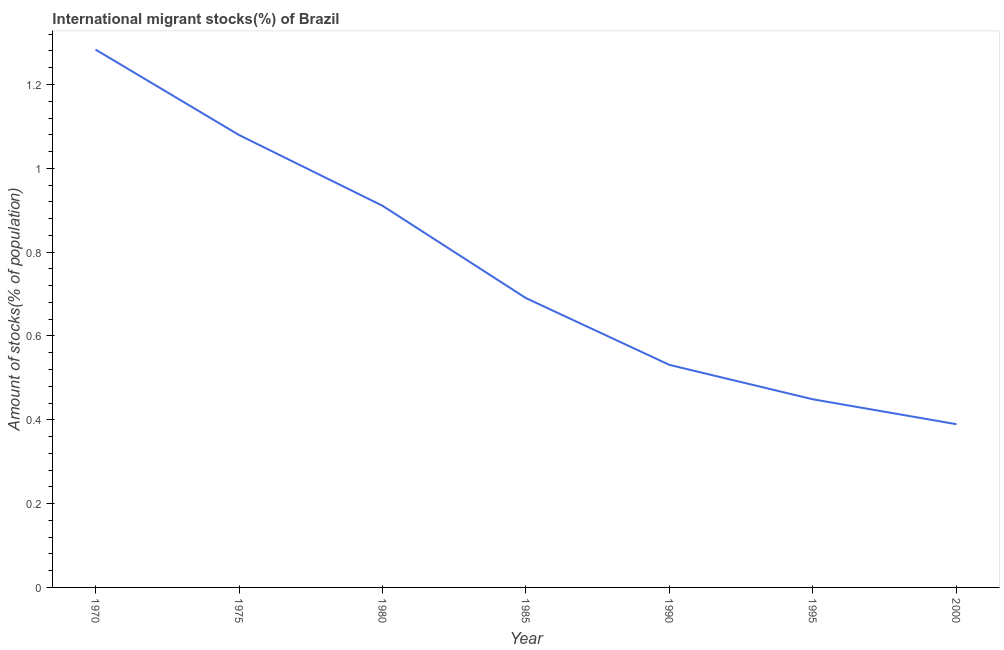What is the number of international migrant stocks in 1980?
Offer a very short reply. 0.91. Across all years, what is the maximum number of international migrant stocks?
Your response must be concise. 1.28. Across all years, what is the minimum number of international migrant stocks?
Give a very brief answer. 0.39. In which year was the number of international migrant stocks maximum?
Your answer should be very brief. 1970. In which year was the number of international migrant stocks minimum?
Offer a very short reply. 2000. What is the sum of the number of international migrant stocks?
Offer a very short reply. 5.33. What is the difference between the number of international migrant stocks in 1985 and 1995?
Make the answer very short. 0.24. What is the average number of international migrant stocks per year?
Your response must be concise. 0.76. What is the median number of international migrant stocks?
Make the answer very short. 0.69. In how many years, is the number of international migrant stocks greater than 0.6000000000000001 %?
Your response must be concise. 4. Do a majority of the years between 1995 and 1970 (inclusive) have number of international migrant stocks greater than 0.28 %?
Offer a very short reply. Yes. What is the ratio of the number of international migrant stocks in 1975 to that in 1985?
Offer a very short reply. 1.56. Is the difference between the number of international migrant stocks in 1970 and 1980 greater than the difference between any two years?
Keep it short and to the point. No. What is the difference between the highest and the second highest number of international migrant stocks?
Your answer should be compact. 0.2. Is the sum of the number of international migrant stocks in 1970 and 1990 greater than the maximum number of international migrant stocks across all years?
Offer a terse response. Yes. What is the difference between the highest and the lowest number of international migrant stocks?
Offer a terse response. 0.89. In how many years, is the number of international migrant stocks greater than the average number of international migrant stocks taken over all years?
Give a very brief answer. 3. What is the difference between two consecutive major ticks on the Y-axis?
Provide a succinct answer. 0.2. Does the graph contain any zero values?
Your response must be concise. No. What is the title of the graph?
Your answer should be very brief. International migrant stocks(%) of Brazil. What is the label or title of the X-axis?
Provide a short and direct response. Year. What is the label or title of the Y-axis?
Your answer should be compact. Amount of stocks(% of population). What is the Amount of stocks(% of population) of 1970?
Your response must be concise. 1.28. What is the Amount of stocks(% of population) of 1975?
Give a very brief answer. 1.08. What is the Amount of stocks(% of population) of 1980?
Your answer should be very brief. 0.91. What is the Amount of stocks(% of population) in 1985?
Ensure brevity in your answer.  0.69. What is the Amount of stocks(% of population) of 1990?
Give a very brief answer. 0.53. What is the Amount of stocks(% of population) of 1995?
Your response must be concise. 0.45. What is the Amount of stocks(% of population) in 2000?
Give a very brief answer. 0.39. What is the difference between the Amount of stocks(% of population) in 1970 and 1975?
Make the answer very short. 0.2. What is the difference between the Amount of stocks(% of population) in 1970 and 1980?
Your answer should be very brief. 0.37. What is the difference between the Amount of stocks(% of population) in 1970 and 1985?
Provide a short and direct response. 0.59. What is the difference between the Amount of stocks(% of population) in 1970 and 1990?
Your answer should be very brief. 0.75. What is the difference between the Amount of stocks(% of population) in 1970 and 1995?
Offer a terse response. 0.83. What is the difference between the Amount of stocks(% of population) in 1970 and 2000?
Provide a succinct answer. 0.89. What is the difference between the Amount of stocks(% of population) in 1975 and 1980?
Keep it short and to the point. 0.17. What is the difference between the Amount of stocks(% of population) in 1975 and 1985?
Offer a very short reply. 0.39. What is the difference between the Amount of stocks(% of population) in 1975 and 1990?
Offer a very short reply. 0.55. What is the difference between the Amount of stocks(% of population) in 1975 and 1995?
Offer a very short reply. 0.63. What is the difference between the Amount of stocks(% of population) in 1975 and 2000?
Keep it short and to the point. 0.69. What is the difference between the Amount of stocks(% of population) in 1980 and 1985?
Your response must be concise. 0.22. What is the difference between the Amount of stocks(% of population) in 1980 and 1990?
Your response must be concise. 0.38. What is the difference between the Amount of stocks(% of population) in 1980 and 1995?
Provide a short and direct response. 0.46. What is the difference between the Amount of stocks(% of population) in 1980 and 2000?
Keep it short and to the point. 0.52. What is the difference between the Amount of stocks(% of population) in 1985 and 1990?
Ensure brevity in your answer.  0.16. What is the difference between the Amount of stocks(% of population) in 1985 and 1995?
Provide a succinct answer. 0.24. What is the difference between the Amount of stocks(% of population) in 1985 and 2000?
Your answer should be compact. 0.3. What is the difference between the Amount of stocks(% of population) in 1990 and 1995?
Keep it short and to the point. 0.08. What is the difference between the Amount of stocks(% of population) in 1990 and 2000?
Give a very brief answer. 0.14. What is the difference between the Amount of stocks(% of population) in 1995 and 2000?
Your response must be concise. 0.06. What is the ratio of the Amount of stocks(% of population) in 1970 to that in 1975?
Offer a very short reply. 1.19. What is the ratio of the Amount of stocks(% of population) in 1970 to that in 1980?
Your answer should be very brief. 1.41. What is the ratio of the Amount of stocks(% of population) in 1970 to that in 1985?
Your answer should be compact. 1.86. What is the ratio of the Amount of stocks(% of population) in 1970 to that in 1990?
Offer a very short reply. 2.42. What is the ratio of the Amount of stocks(% of population) in 1970 to that in 1995?
Offer a terse response. 2.86. What is the ratio of the Amount of stocks(% of population) in 1970 to that in 2000?
Provide a short and direct response. 3.29. What is the ratio of the Amount of stocks(% of population) in 1975 to that in 1980?
Ensure brevity in your answer.  1.19. What is the ratio of the Amount of stocks(% of population) in 1975 to that in 1985?
Provide a short and direct response. 1.56. What is the ratio of the Amount of stocks(% of population) in 1975 to that in 1990?
Provide a short and direct response. 2.03. What is the ratio of the Amount of stocks(% of population) in 1975 to that in 1995?
Your answer should be very brief. 2.4. What is the ratio of the Amount of stocks(% of population) in 1975 to that in 2000?
Your answer should be very brief. 2.77. What is the ratio of the Amount of stocks(% of population) in 1980 to that in 1985?
Your answer should be compact. 1.32. What is the ratio of the Amount of stocks(% of population) in 1980 to that in 1990?
Make the answer very short. 1.72. What is the ratio of the Amount of stocks(% of population) in 1980 to that in 1995?
Keep it short and to the point. 2.03. What is the ratio of the Amount of stocks(% of population) in 1980 to that in 2000?
Ensure brevity in your answer.  2.34. What is the ratio of the Amount of stocks(% of population) in 1985 to that in 1995?
Your answer should be compact. 1.54. What is the ratio of the Amount of stocks(% of population) in 1985 to that in 2000?
Your answer should be compact. 1.77. What is the ratio of the Amount of stocks(% of population) in 1990 to that in 1995?
Your response must be concise. 1.18. What is the ratio of the Amount of stocks(% of population) in 1990 to that in 2000?
Your response must be concise. 1.36. What is the ratio of the Amount of stocks(% of population) in 1995 to that in 2000?
Offer a very short reply. 1.15. 